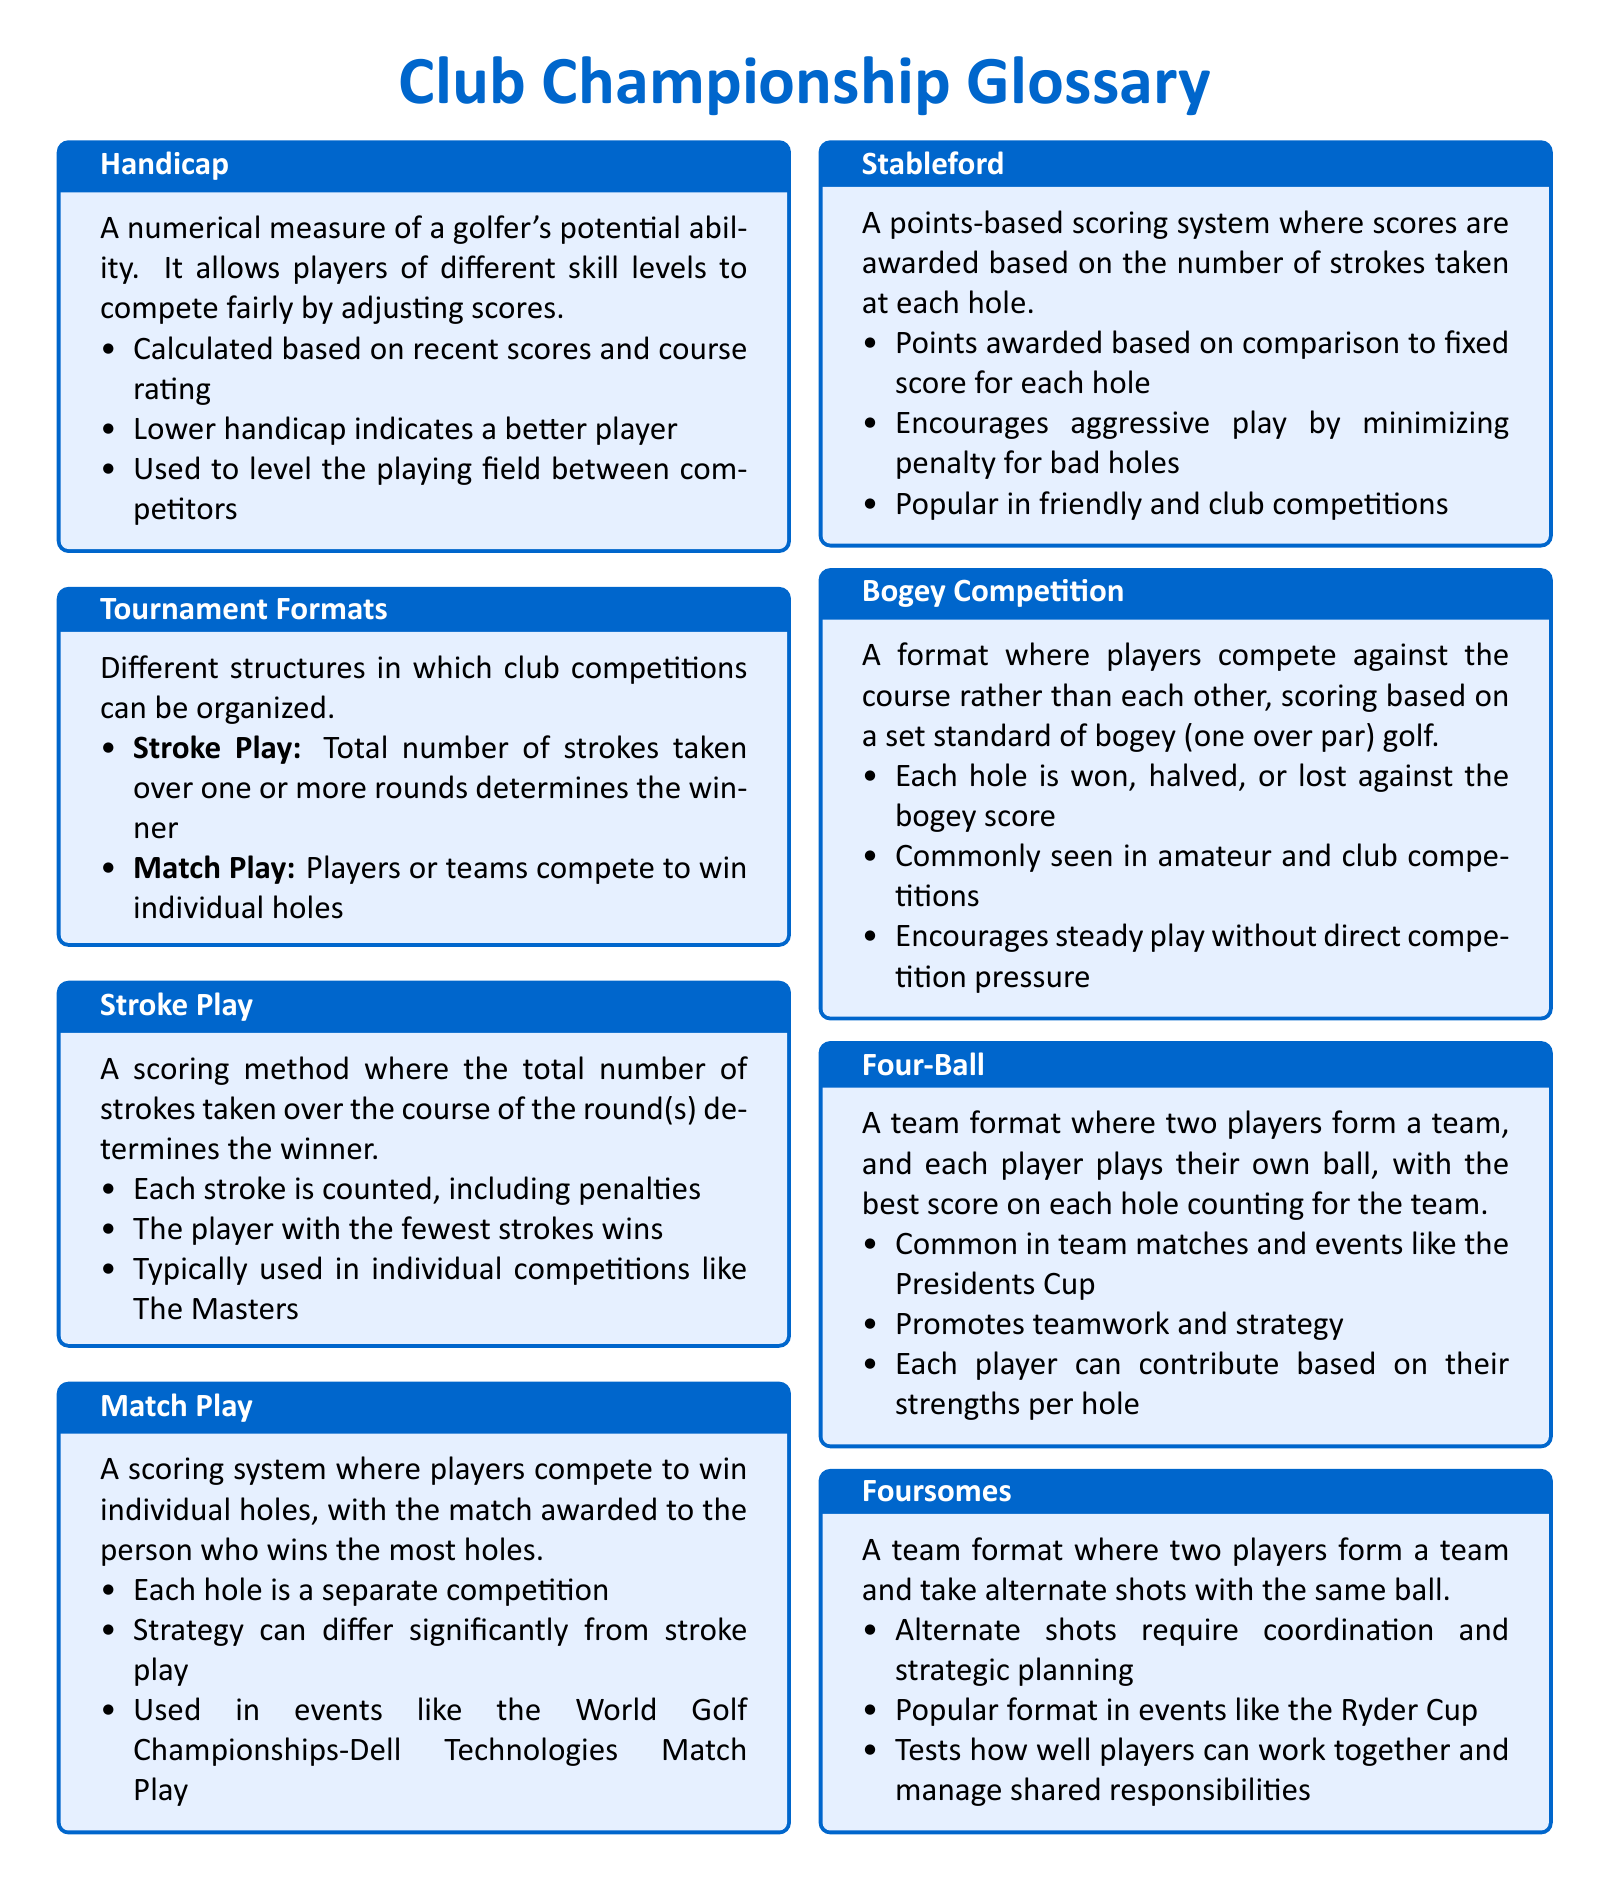What is a handicap? A handicap is a numerical measure of a golfer's potential ability that allows players of different skill levels to compete fairly.
Answer: A numerical measure of a golfer's potential ability What does stroke play determine? Stroke play determines the winner based on the total number of strokes taken over the round(s).
Answer: The total number of strokes taken What is the purpose of the Stableford scoring system? The Stableford scoring system awards points based on the number of strokes taken at each hole compared to a fixed score.
Answer: Points-based scoring system In which format do players take alternate shots? Players take alternate shots in the Foursomes format.
Answer: Foursomes What type of competition does a Bogey Competition emphasize? A Bogey Competition emphasizes competition against the course rather than other players.
Answer: Competing against the course Which team format involves two players playing their own ball? The team format that involves two players playing their own ball is called Four-Ball.
Answer: Four-Ball 